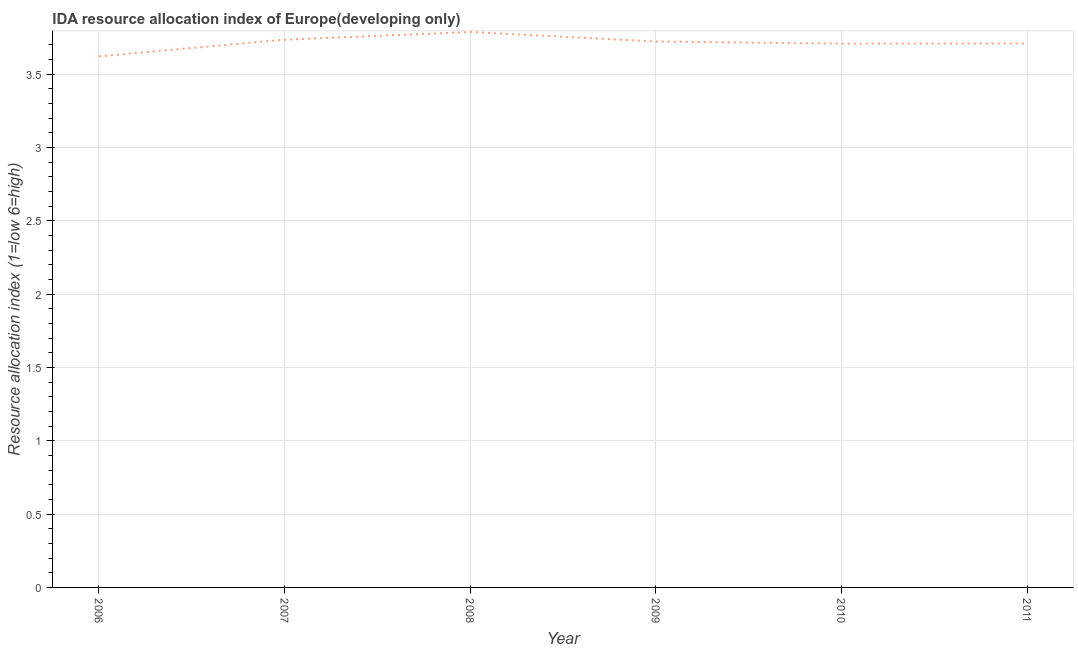What is the ida resource allocation index in 2011?
Give a very brief answer. 3.71. Across all years, what is the maximum ida resource allocation index?
Provide a short and direct response. 3.79. Across all years, what is the minimum ida resource allocation index?
Your response must be concise. 3.62. What is the sum of the ida resource allocation index?
Give a very brief answer. 22.29. What is the difference between the ida resource allocation index in 2009 and 2011?
Your response must be concise. 0.01. What is the average ida resource allocation index per year?
Your response must be concise. 3.71. What is the median ida resource allocation index?
Offer a very short reply. 3.72. In how many years, is the ida resource allocation index greater than 2.4 ?
Offer a terse response. 6. What is the ratio of the ida resource allocation index in 2007 to that in 2010?
Offer a very short reply. 1.01. Is the ida resource allocation index in 2008 less than that in 2010?
Ensure brevity in your answer.  No. What is the difference between the highest and the second highest ida resource allocation index?
Ensure brevity in your answer.  0.05. What is the difference between the highest and the lowest ida resource allocation index?
Offer a very short reply. 0.17. How many lines are there?
Your response must be concise. 1. How many years are there in the graph?
Your answer should be very brief. 6. What is the difference between two consecutive major ticks on the Y-axis?
Your response must be concise. 0.5. Does the graph contain grids?
Your answer should be very brief. Yes. What is the title of the graph?
Provide a succinct answer. IDA resource allocation index of Europe(developing only). What is the label or title of the X-axis?
Your answer should be very brief. Year. What is the label or title of the Y-axis?
Keep it short and to the point. Resource allocation index (1=low 6=high). What is the Resource allocation index (1=low 6=high) in 2006?
Make the answer very short. 3.62. What is the Resource allocation index (1=low 6=high) in 2007?
Provide a short and direct response. 3.74. What is the Resource allocation index (1=low 6=high) of 2008?
Offer a terse response. 3.79. What is the Resource allocation index (1=low 6=high) in 2009?
Provide a succinct answer. 3.72. What is the Resource allocation index (1=low 6=high) of 2010?
Provide a short and direct response. 3.71. What is the Resource allocation index (1=low 6=high) of 2011?
Make the answer very short. 3.71. What is the difference between the Resource allocation index (1=low 6=high) in 2006 and 2007?
Your answer should be very brief. -0.11. What is the difference between the Resource allocation index (1=low 6=high) in 2006 and 2008?
Offer a terse response. -0.17. What is the difference between the Resource allocation index (1=low 6=high) in 2006 and 2009?
Provide a succinct answer. -0.1. What is the difference between the Resource allocation index (1=low 6=high) in 2006 and 2010?
Your response must be concise. -0.09. What is the difference between the Resource allocation index (1=low 6=high) in 2006 and 2011?
Keep it short and to the point. -0.09. What is the difference between the Resource allocation index (1=low 6=high) in 2007 and 2008?
Ensure brevity in your answer.  -0.05. What is the difference between the Resource allocation index (1=low 6=high) in 2007 and 2009?
Keep it short and to the point. 0.01. What is the difference between the Resource allocation index (1=low 6=high) in 2007 and 2010?
Your response must be concise. 0.03. What is the difference between the Resource allocation index (1=low 6=high) in 2007 and 2011?
Your answer should be compact. 0.03. What is the difference between the Resource allocation index (1=low 6=high) in 2008 and 2009?
Keep it short and to the point. 0.06. What is the difference between the Resource allocation index (1=low 6=high) in 2008 and 2010?
Ensure brevity in your answer.  0.08. What is the difference between the Resource allocation index (1=low 6=high) in 2008 and 2011?
Offer a very short reply. 0.08. What is the difference between the Resource allocation index (1=low 6=high) in 2009 and 2010?
Give a very brief answer. 0.01. What is the difference between the Resource allocation index (1=low 6=high) in 2009 and 2011?
Make the answer very short. 0.01. What is the difference between the Resource allocation index (1=low 6=high) in 2010 and 2011?
Provide a short and direct response. -0. What is the ratio of the Resource allocation index (1=low 6=high) in 2006 to that in 2007?
Offer a very short reply. 0.97. What is the ratio of the Resource allocation index (1=low 6=high) in 2006 to that in 2008?
Your answer should be compact. 0.96. What is the ratio of the Resource allocation index (1=low 6=high) in 2006 to that in 2010?
Offer a terse response. 0.98. What is the ratio of the Resource allocation index (1=low 6=high) in 2006 to that in 2011?
Keep it short and to the point. 0.98. What is the ratio of the Resource allocation index (1=low 6=high) in 2007 to that in 2009?
Provide a succinct answer. 1. What is the ratio of the Resource allocation index (1=low 6=high) in 2007 to that in 2010?
Your answer should be compact. 1.01. What is the ratio of the Resource allocation index (1=low 6=high) in 2007 to that in 2011?
Offer a very short reply. 1.01. What is the ratio of the Resource allocation index (1=low 6=high) in 2008 to that in 2010?
Your response must be concise. 1.02. What is the ratio of the Resource allocation index (1=low 6=high) in 2008 to that in 2011?
Provide a succinct answer. 1.02. What is the ratio of the Resource allocation index (1=low 6=high) in 2009 to that in 2010?
Provide a short and direct response. 1. What is the ratio of the Resource allocation index (1=low 6=high) in 2010 to that in 2011?
Provide a short and direct response. 1. 